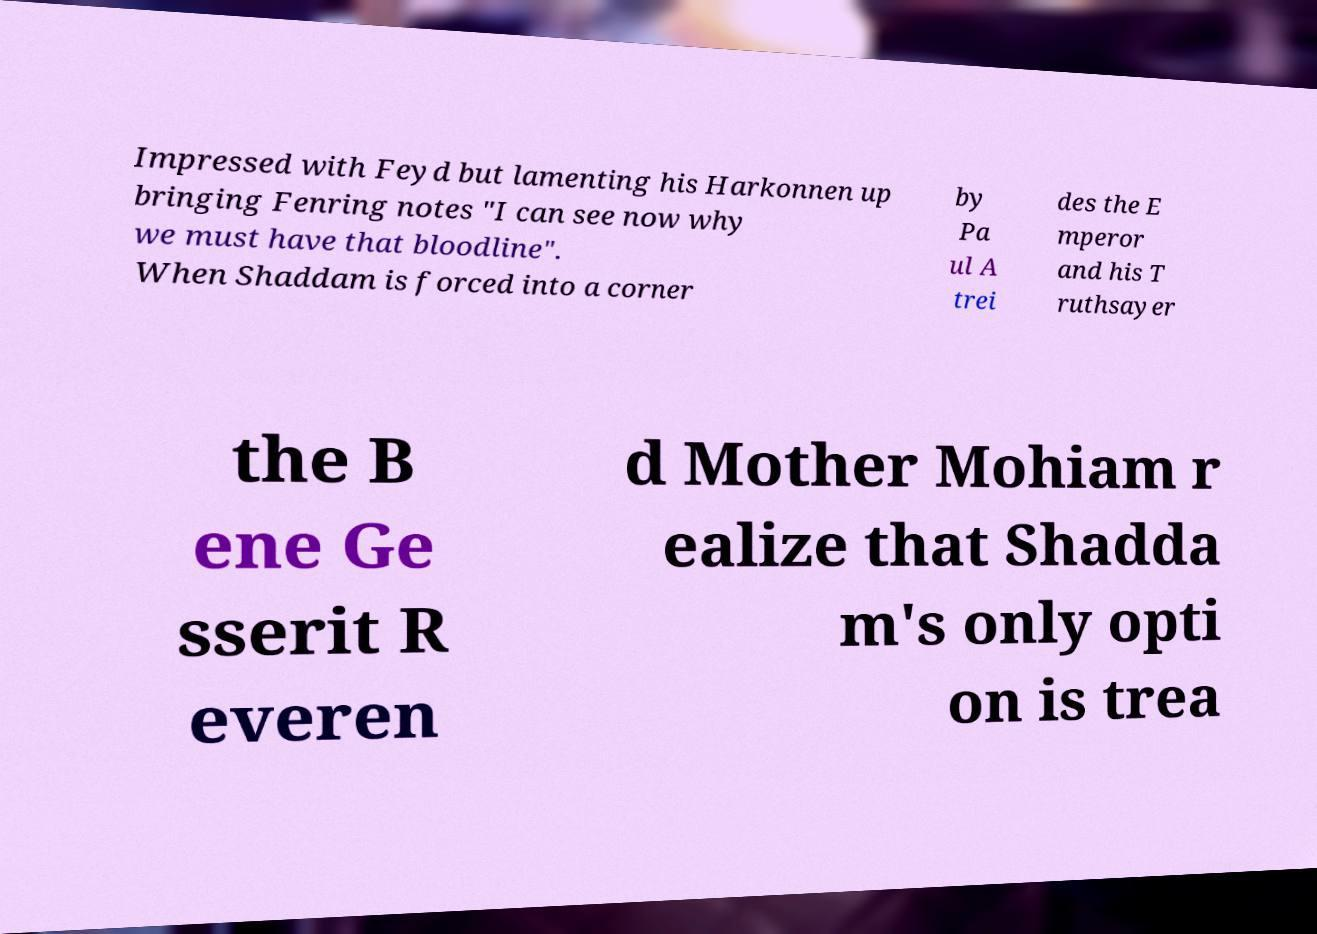For documentation purposes, I need the text within this image transcribed. Could you provide that? Impressed with Feyd but lamenting his Harkonnen up bringing Fenring notes "I can see now why we must have that bloodline". When Shaddam is forced into a corner by Pa ul A trei des the E mperor and his T ruthsayer the B ene Ge sserit R everen d Mother Mohiam r ealize that Shadda m's only opti on is trea 